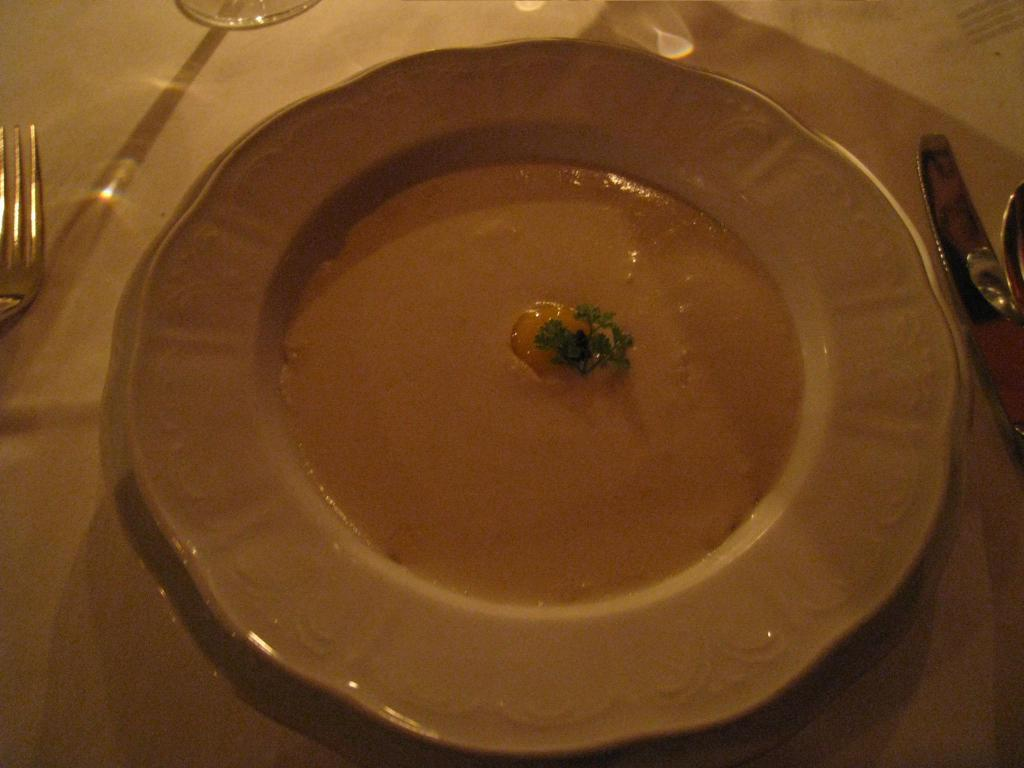What is present on the plate in the image? There are eatables on the plate in the image. What is the color of the plate? The plate is white in color. What utensils are present near the plate? There is a fork on the left side of the plate and a knife on the right side of the plate. Can you see a farmer working in the wilderness in the image? No, there is no farmer or wilderness present in the image. 